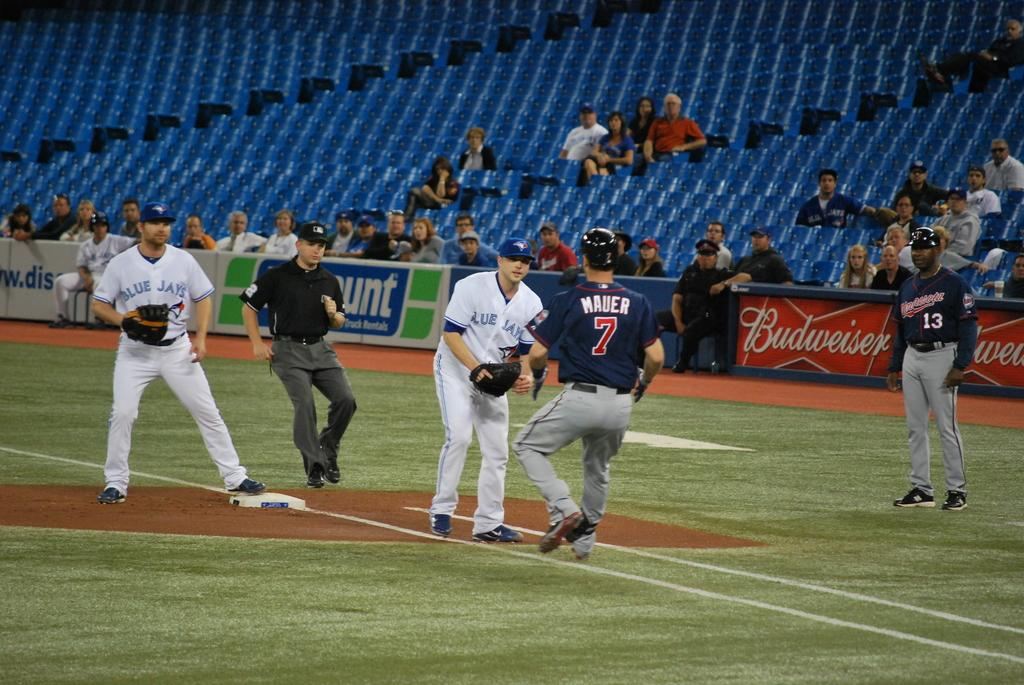<image>
Write a terse but informative summary of the picture. some baseball players, one with the number 7 on 